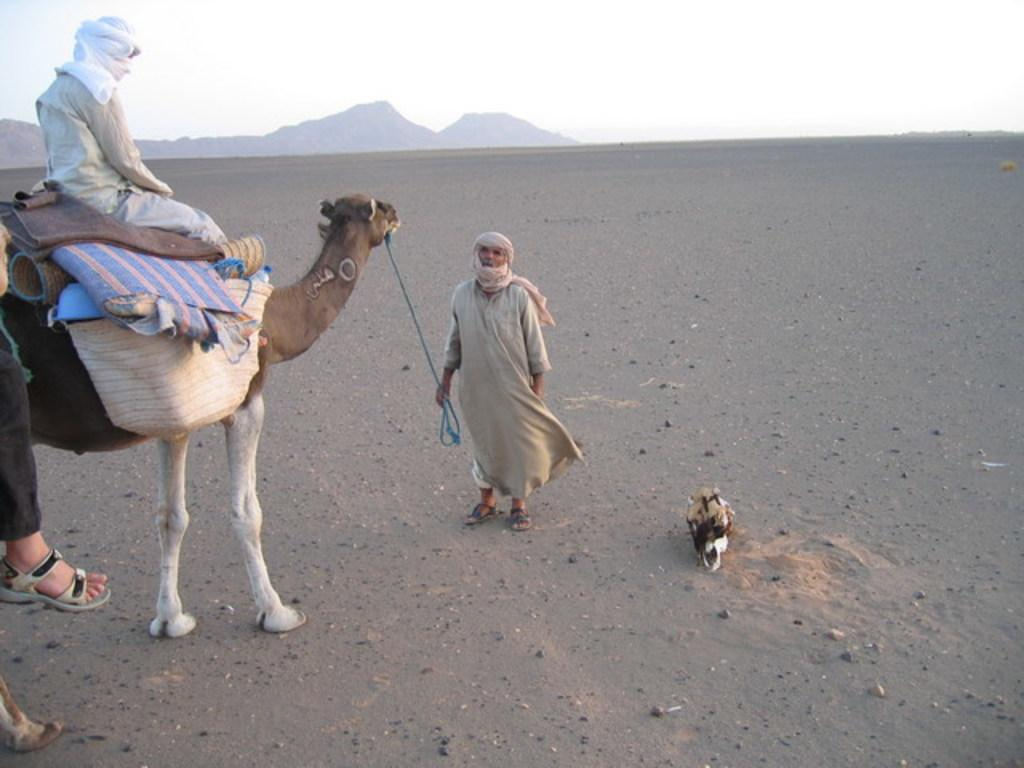What is the man on the left side of the image doing? The man is sitting on a camel on the left side of the image. Where is the camel located? The camel is on a desert. What is the man in the middle of the image holding? The man is holding a rope in the middle of the image. What can be seen in the distance in the image? There are hills visible in the background of the image. What is visible above the hills? The sky is visible above the hills. What type of form can be seen in the image? There is no specific form mentioned in the image; it features a man sitting on a camel, a man holding a rope, a desert, hills, and the sky. How many cans are visible in the image? There are no cans present in the image. 